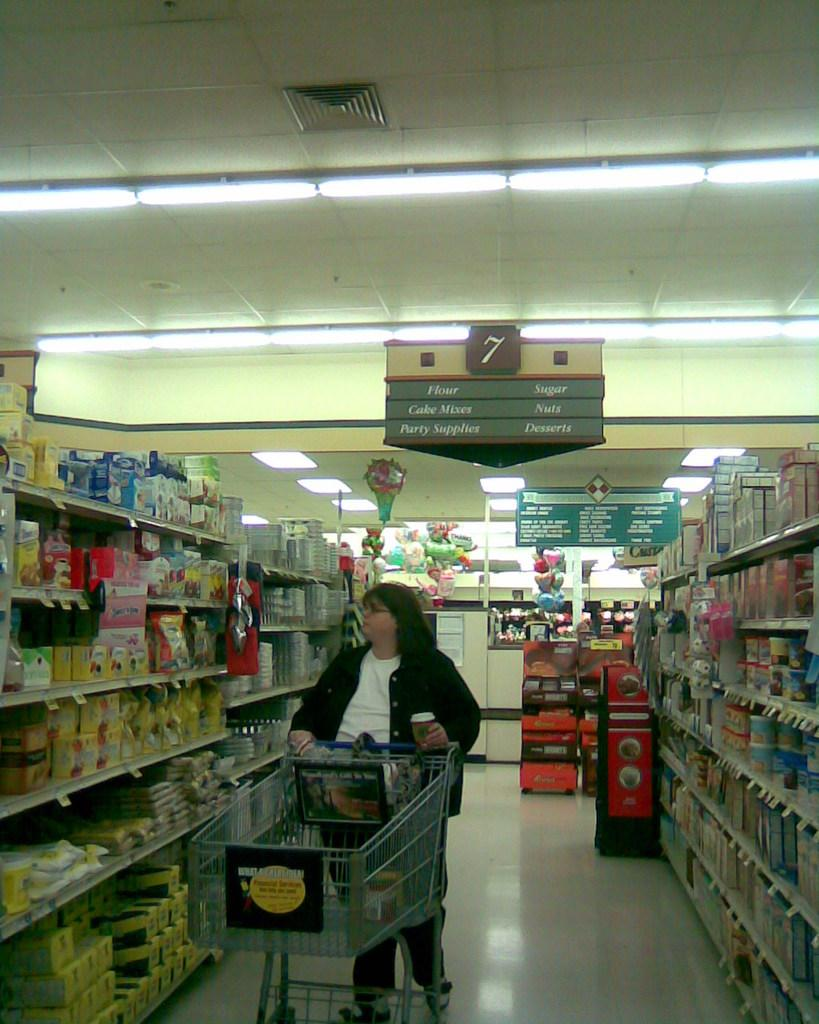Provide a one-sentence caption for the provided image. A woman pushes a trolly in a supermarket below a sign that describes the aisle as a bakery section. 